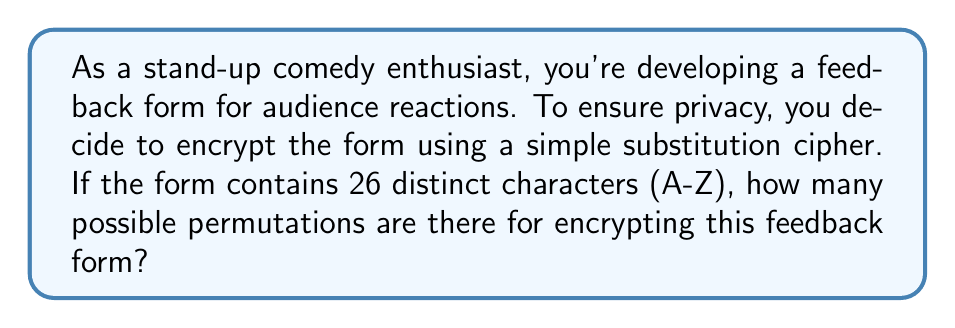Could you help me with this problem? Let's approach this step-by-step:

1) A simple substitution cipher replaces each letter in the plaintext with a different letter in the ciphertext.

2) We have 26 distinct characters (A-Z) in our feedback form.

3) For the first character, we have 26 choices to substitute it with.

4) For the second character, we have 25 choices left, as we can't use the letter we used for the first character.

5) For the third character, we have 24 choices, and so on.

6) This continues until we reach the last character, for which we'll have only 1 choice left.

7) This scenario describes a permutation of 26 elements.

8) The number of permutations of n distinct objects is given by the factorial of n, denoted as n!

9) In this case, we need to calculate 26!

10) 26! = 26 × 25 × 24 × ... × 3 × 2 × 1

11) Using a calculator (as this is a very large number):

    $$26! = 403,291,461,126,605,635,584,000,000$$

This enormous number represents the total number of possible ways to encrypt your feedback form using a simple substitution cipher.
Answer: $$403,291,461,126,605,635,584,000,000$$ 